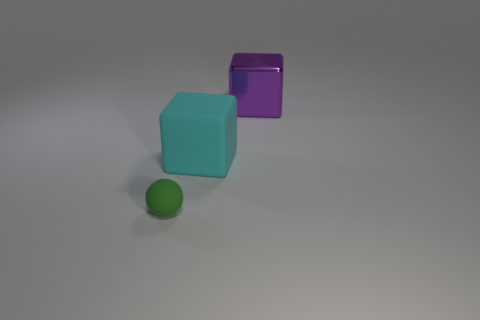Subtract 1 blocks. How many blocks are left? 1 Subtract all cyan cubes. How many cubes are left? 1 Add 2 small brown cylinders. How many objects exist? 5 Subtract all balls. How many objects are left? 2 Subtract all big things. Subtract all green rubber objects. How many objects are left? 0 Add 2 rubber cubes. How many rubber cubes are left? 3 Add 2 small matte spheres. How many small matte spheres exist? 3 Subtract 0 red spheres. How many objects are left? 3 Subtract all purple blocks. Subtract all purple balls. How many blocks are left? 1 Subtract all purple spheres. How many yellow blocks are left? 0 